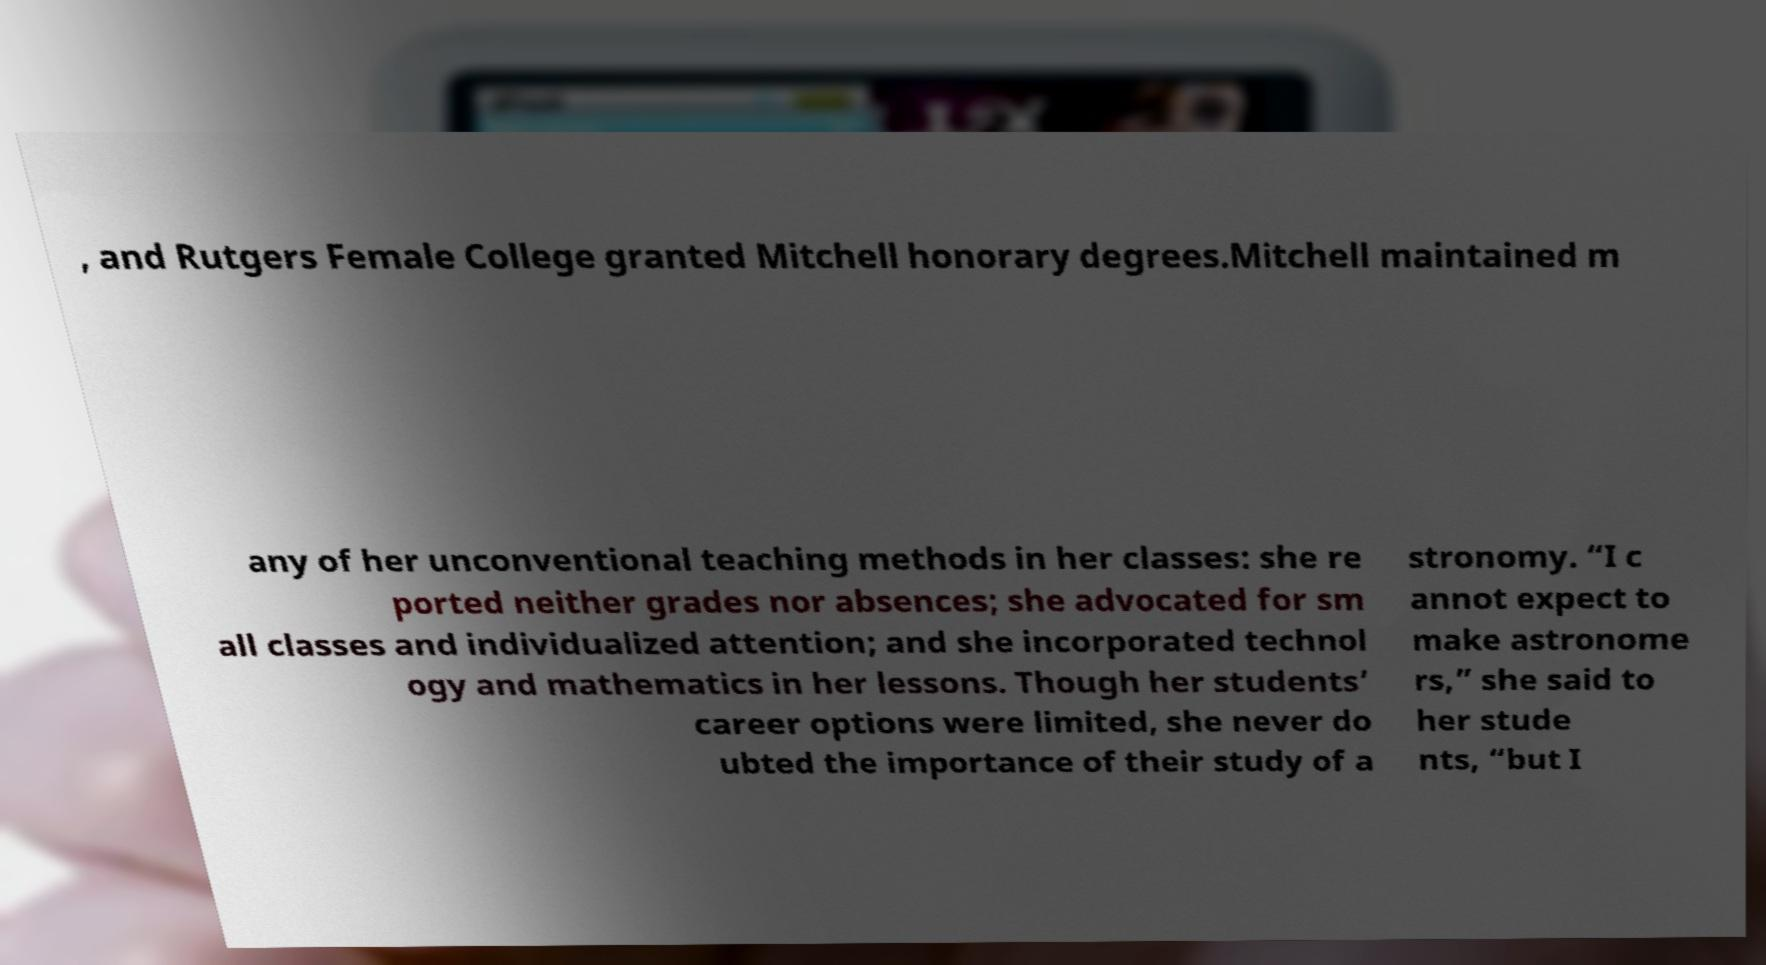Please read and relay the text visible in this image. What does it say? , and Rutgers Female College granted Mitchell honorary degrees.Mitchell maintained m any of her unconventional teaching methods in her classes: she re ported neither grades nor absences; she advocated for sm all classes and individualized attention; and she incorporated technol ogy and mathematics in her lessons. Though her students’ career options were limited, she never do ubted the importance of their study of a stronomy. “I c annot expect to make astronome rs,” she said to her stude nts, “but I 